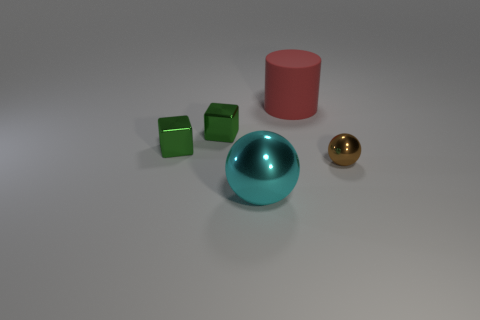There is a thing that is both to the right of the large metal thing and in front of the red thing; what is its shape? The object you're referring to is a sphere and appears to have a turquoise hue, complementing the contrasting colors of nearby objects. 